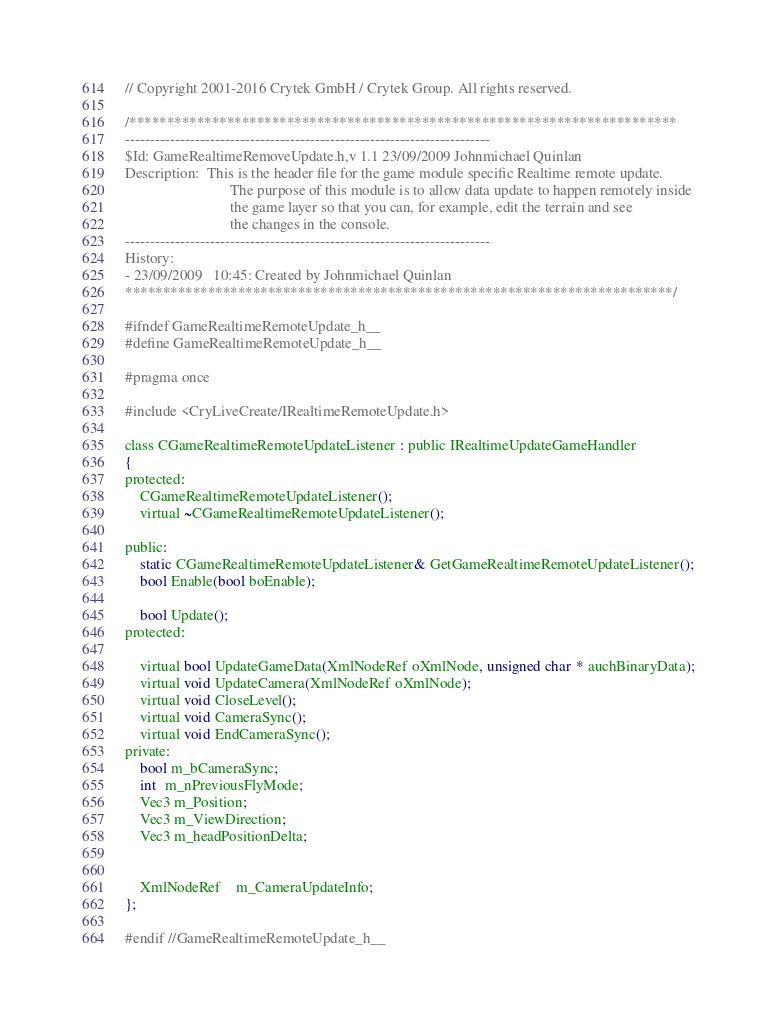Convert code to text. <code><loc_0><loc_0><loc_500><loc_500><_C_>// Copyright 2001-2016 Crytek GmbH / Crytek Group. All rights reserved.

/*************************************************************************
-------------------------------------------------------------------------
$Id: GameRealtimeRemoveUpdate.h,v 1.1 23/09/2009 Johnmichael Quinlan
Description:  This is the header file for the game module specific Realtime remote update. 
							The purpose of this module is to allow data update to happen remotely inside 
							the game layer so that you can, for example, edit the terrain and see 
							the changes in the console.
-------------------------------------------------------------------------
History:
- 23/09/2009   10:45: Created by Johnmichael Quinlan
*************************************************************************/

#ifndef GameRealtimeRemoteUpdate_h__
#define GameRealtimeRemoteUpdate_h__

#pragma once

#include <CryLiveCreate/IRealtimeRemoteUpdate.h>

class CGameRealtimeRemoteUpdateListener : public IRealtimeUpdateGameHandler
{
protected:
	CGameRealtimeRemoteUpdateListener();
	virtual ~CGameRealtimeRemoteUpdateListener();

public:
	static CGameRealtimeRemoteUpdateListener& GetGameRealtimeRemoteUpdateListener();
	bool Enable(bool boEnable);

	bool Update();
protected:
	
	virtual bool UpdateGameData(XmlNodeRef oXmlNode, unsigned char * auchBinaryData);
	virtual void UpdateCamera(XmlNodeRef oXmlNode);
	virtual void CloseLevel();
	virtual void CameraSync();
	virtual void EndCameraSync();
private:
	bool m_bCameraSync;
	int  m_nPreviousFlyMode;
	Vec3 m_Position;
	Vec3 m_ViewDirection;
	Vec3 m_headPositionDelta;


	XmlNodeRef	m_CameraUpdateInfo;
};

#endif //GameRealtimeRemoteUpdate_h__

</code> 